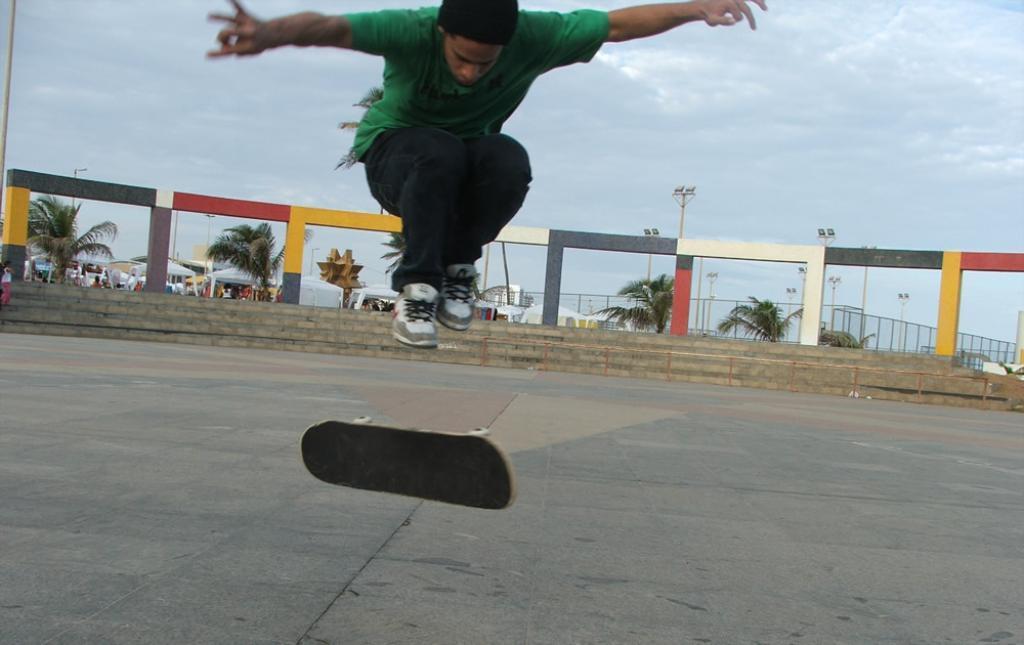How would you summarize this image in a sentence or two? In this picture we can see a man and a skateboard is in the air, steps, poles, trees, fence, stalls and in the background we can see the sky with clouds. 